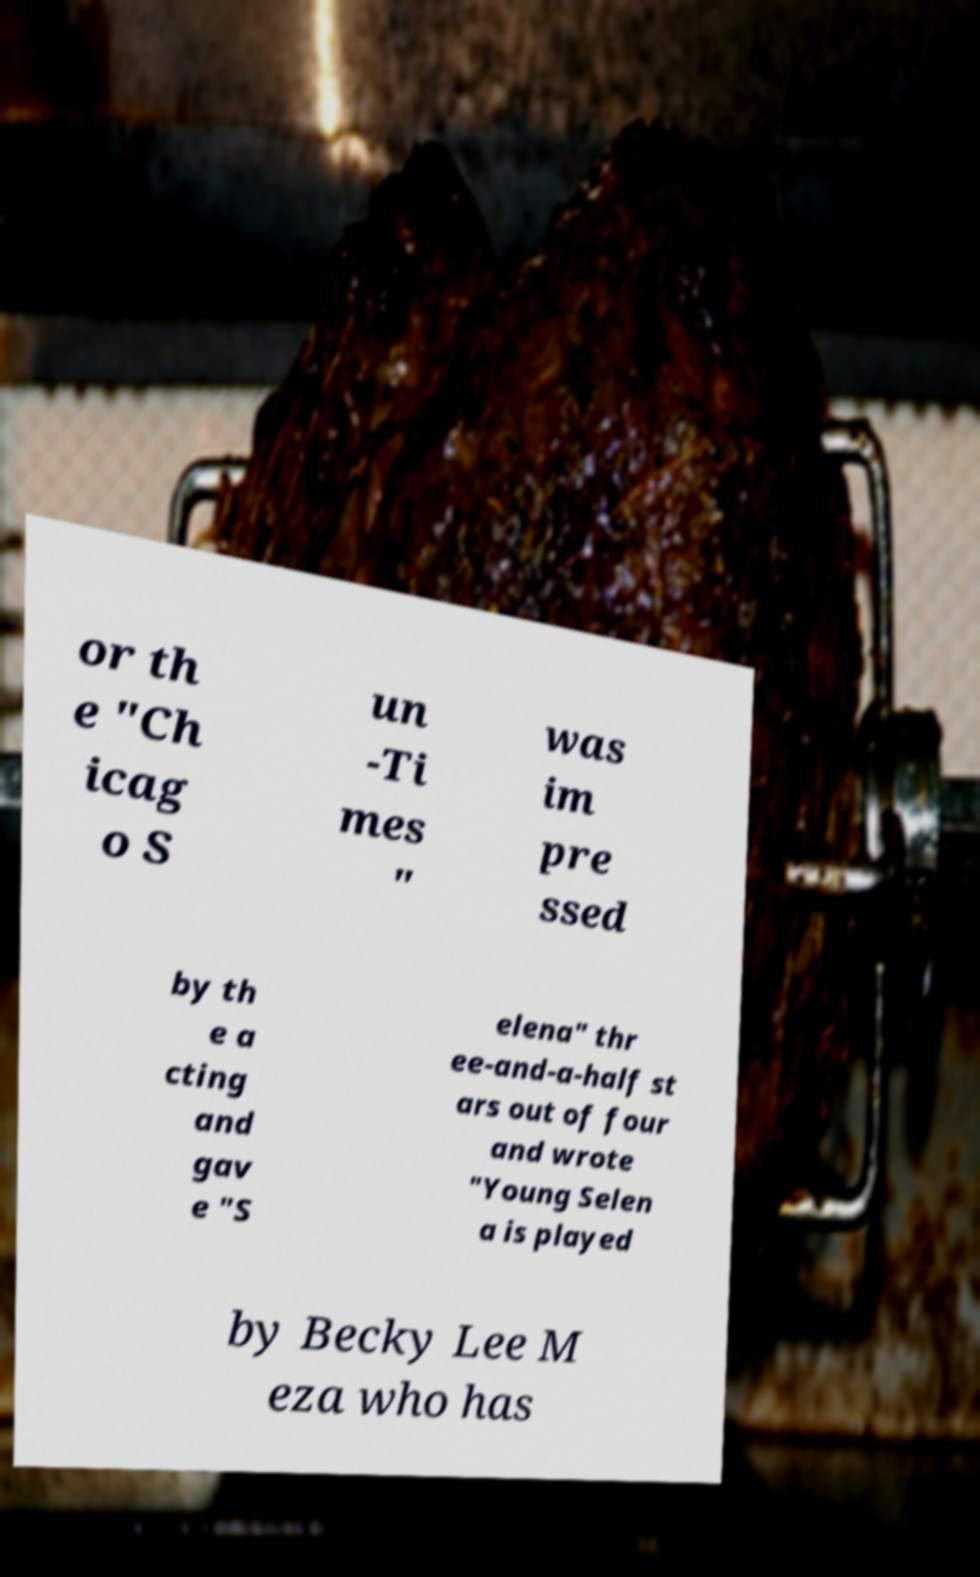Can you accurately transcribe the text from the provided image for me? or th e "Ch icag o S un -Ti mes " was im pre ssed by th e a cting and gav e "S elena" thr ee-and-a-half st ars out of four and wrote "Young Selen a is played by Becky Lee M eza who has 